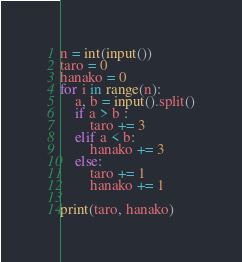Convert code to text. <code><loc_0><loc_0><loc_500><loc_500><_Python_>n = int(input())
taro = 0
hanako = 0
for i in range(n):
    a, b = input().split()
    if a > b :
        taro += 3
    elif a < b:
        hanako += 3
    else:
        taro += 1
        hanako += 1

print(taro, hanako)

</code> 